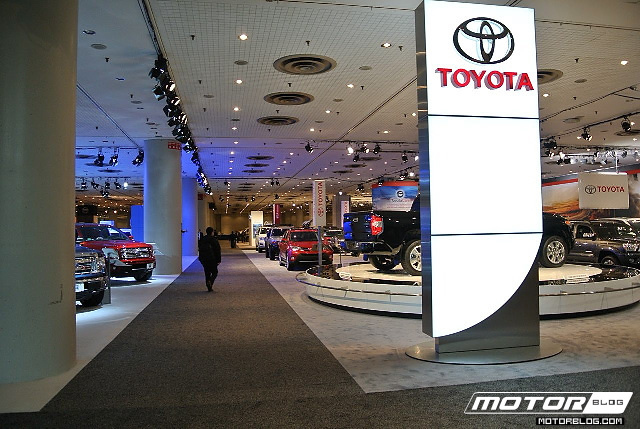Please identify all text content in this image. TOYOTA TOYOTA MOTORBLOG.COM BLOG MOTOR 